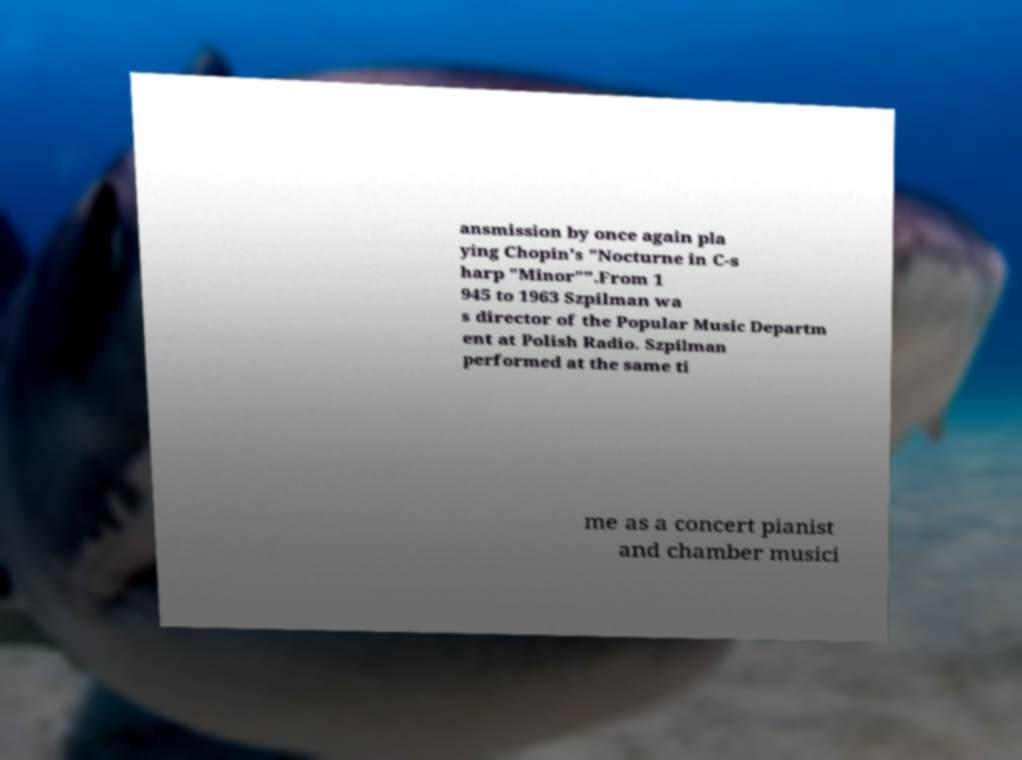Can you read and provide the text displayed in the image?This photo seems to have some interesting text. Can you extract and type it out for me? ansmission by once again pla ying Chopin's "Nocturne in C-s harp "Minor"".From 1 945 to 1963 Szpilman wa s director of the Popular Music Departm ent at Polish Radio. Szpilman performed at the same ti me as a concert pianist and chamber musici 